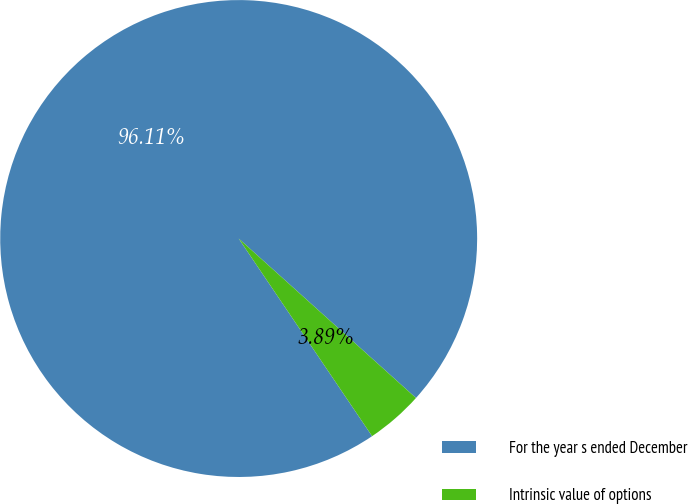<chart> <loc_0><loc_0><loc_500><loc_500><pie_chart><fcel>For the year s ended December<fcel>Intrinsic value of options<nl><fcel>96.11%<fcel>3.89%<nl></chart> 